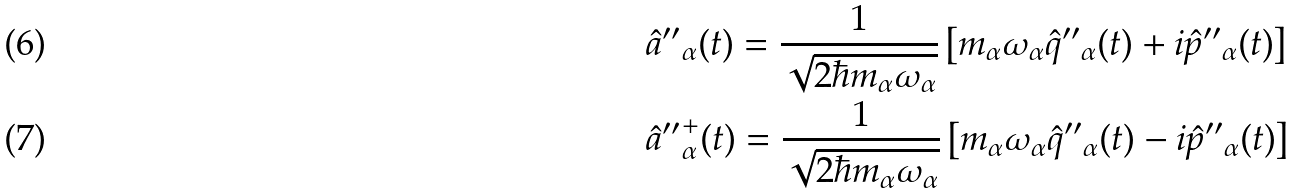Convert formula to latex. <formula><loc_0><loc_0><loc_500><loc_500>& \hat { a } { ^ { \prime \prime } } _ { \alpha } ( t ) = \frac { 1 } { \sqrt { 2 \hbar { m } _ { \alpha } \omega _ { \alpha } } } \left [ m _ { \alpha } \omega _ { \alpha } \hat { q } { ^ { \prime \prime } } _ { \alpha } ( t ) + i \hat { p } { ^ { \prime \prime } } _ { \alpha } ( t ) \right ] \\ & \hat { a } { ^ { \prime \prime } } ^ { + } _ { \alpha } ( t ) = \frac { 1 } { \sqrt { 2 \hbar { m } _ { \alpha } \omega _ { \alpha } } } \left [ m _ { \alpha } \omega _ { \alpha } \hat { q } { ^ { \prime \prime } } _ { \alpha } ( t ) - i \hat { p } { ^ { \prime \prime } } _ { \alpha } ( t ) \right ]</formula> 